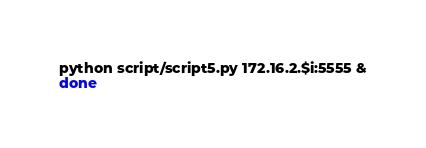<code> <loc_0><loc_0><loc_500><loc_500><_Bash_>python script/script5.py 172.16.2.$i:5555 &
done
</code> 